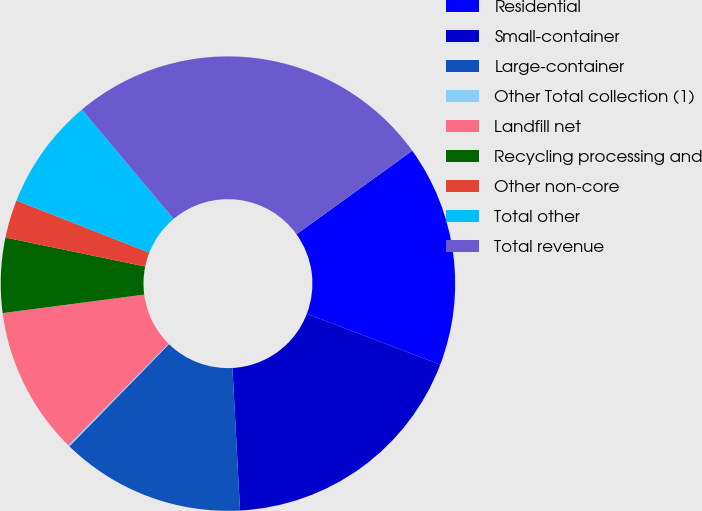Convert chart. <chart><loc_0><loc_0><loc_500><loc_500><pie_chart><fcel>Residential<fcel>Small-container<fcel>Large-container<fcel>Other Total collection (1)<fcel>Landfill net<fcel>Recycling processing and<fcel>Other non-core<fcel>Total other<fcel>Total revenue<nl><fcel>15.74%<fcel>18.35%<fcel>13.14%<fcel>0.11%<fcel>10.53%<fcel>5.32%<fcel>2.71%<fcel>7.93%<fcel>26.17%<nl></chart> 